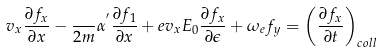<formula> <loc_0><loc_0><loc_500><loc_500>v _ { x } \frac { \partial { f _ { x } } } { \partial { x } } - \frac { } { 2 m } \alpha ^ { ^ { \prime } } \frac { \partial { f _ { 1 } } } { \partial { x } } + e v _ { x } E _ { 0 } \frac { \partial { f _ { x } } } { \partial { \epsilon } } + \omega _ { e } f _ { y } = \left ( \frac { \partial { f _ { x } } } { \partial { t } } \right ) _ { c o l l }</formula> 